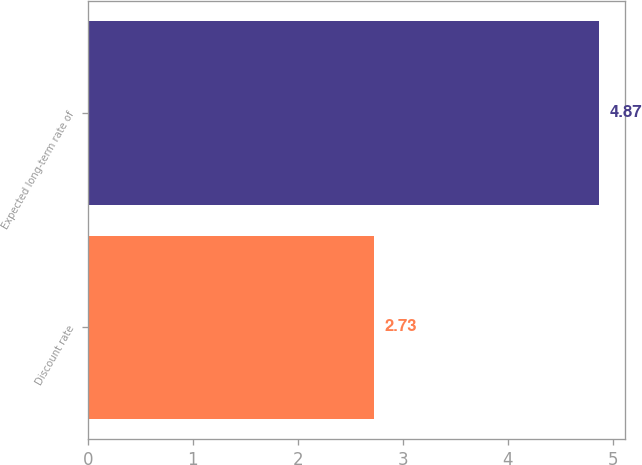Convert chart. <chart><loc_0><loc_0><loc_500><loc_500><bar_chart><fcel>Discount rate<fcel>Expected long-term rate of<nl><fcel>2.73<fcel>4.87<nl></chart> 